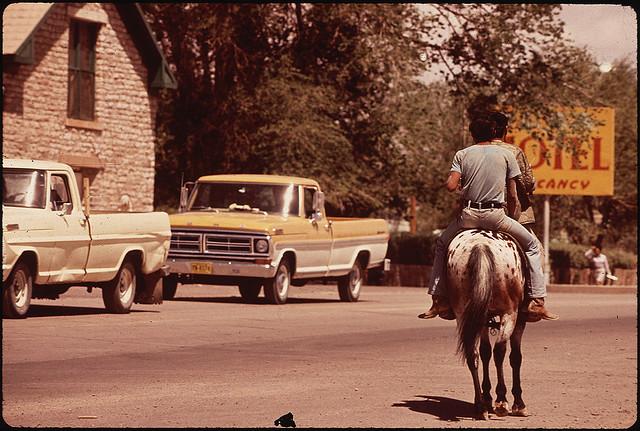What is the sitting man looking through?
Write a very short answer. Glasses. What color is the license plate on the truck?
Give a very brief answer. Yellow. What is the truck bed made out of?
Answer briefly. Metal. Is the animal on a leash?
Answer briefly. No. How many people are on the horse?
Give a very brief answer. 2. What is the guy riding?
Give a very brief answer. Horse. What country is this in?
Give a very brief answer. Usa. Are the trucks brand new?
Answer briefly. No. What color is the truck?
Answer briefly. White. 